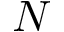Convert formula to latex. <formula><loc_0><loc_0><loc_500><loc_500>N</formula> 